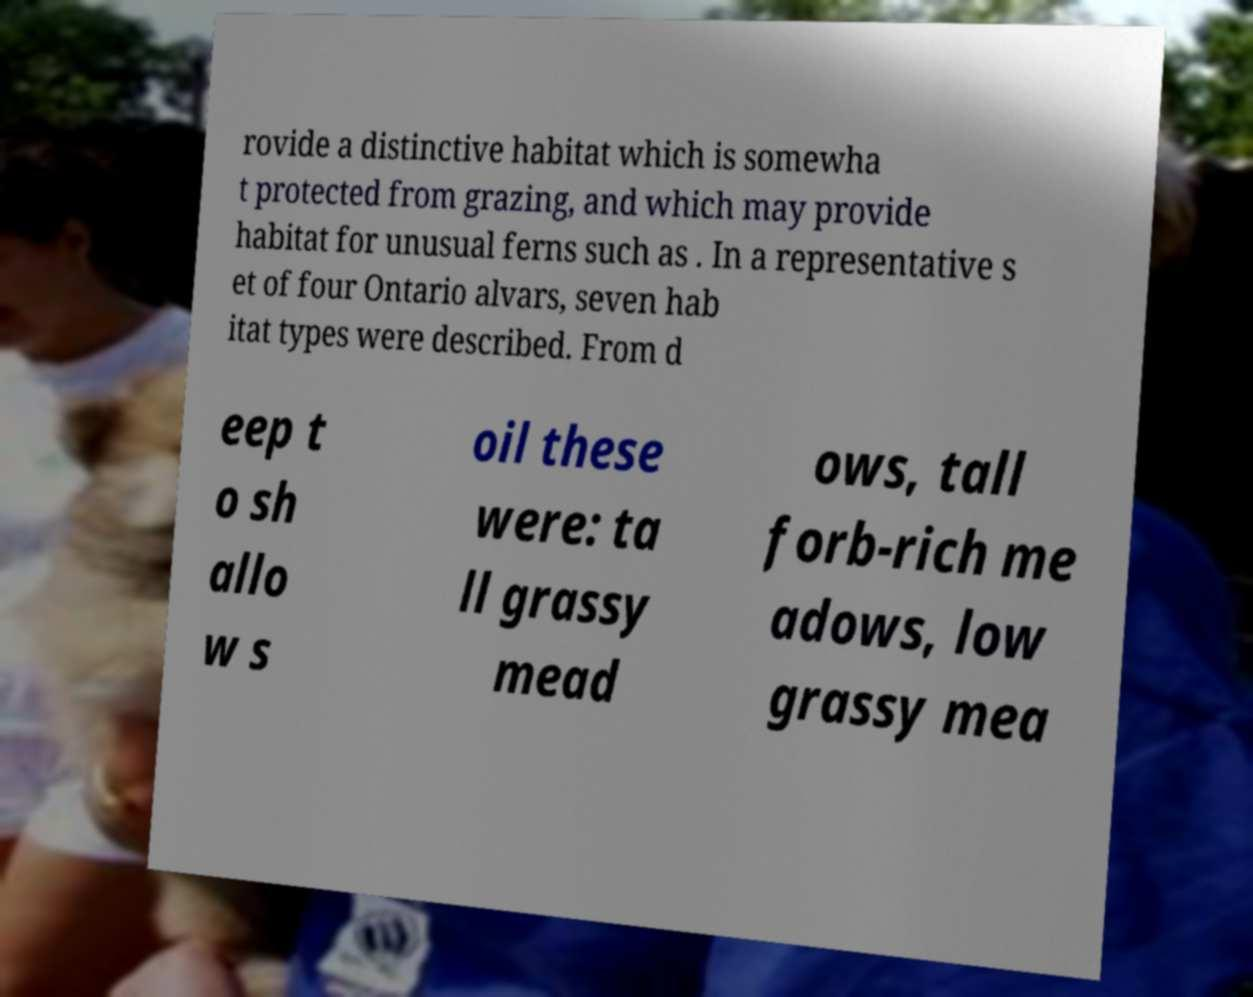Please identify and transcribe the text found in this image. rovide a distinctive habitat which is somewha t protected from grazing, and which may provide habitat for unusual ferns such as . In a representative s et of four Ontario alvars, seven hab itat types were described. From d eep t o sh allo w s oil these were: ta ll grassy mead ows, tall forb-rich me adows, low grassy mea 